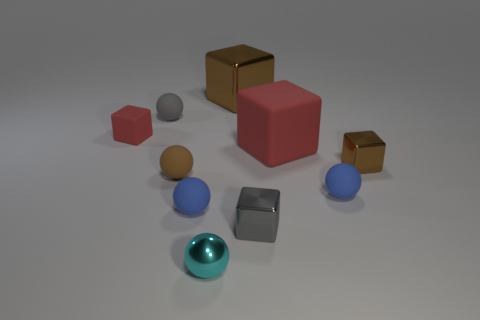Subtract 1 spheres. How many spheres are left? 4 Subtract all cyan balls. How many balls are left? 4 Subtract all brown spheres. How many spheres are left? 4 Subtract all gray cubes. Subtract all purple spheres. How many cubes are left? 4 Subtract 0 brown cylinders. How many objects are left? 10 Subtract all small rubber things. Subtract all large cubes. How many objects are left? 3 Add 5 shiny balls. How many shiny balls are left? 6 Add 2 small matte objects. How many small matte objects exist? 7 